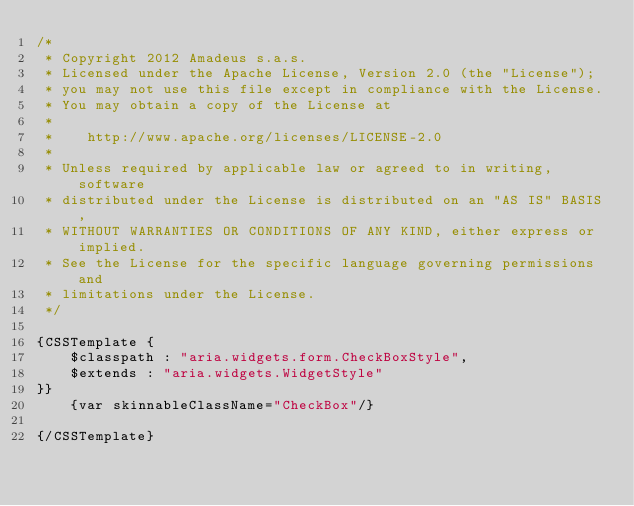Convert code to text. <code><loc_0><loc_0><loc_500><loc_500><_CSS_>/*
 * Copyright 2012 Amadeus s.a.s.
 * Licensed under the Apache License, Version 2.0 (the "License");
 * you may not use this file except in compliance with the License.
 * You may obtain a copy of the License at
 *
 *    http://www.apache.org/licenses/LICENSE-2.0
 *
 * Unless required by applicable law or agreed to in writing, software
 * distributed under the License is distributed on an "AS IS" BASIS,
 * WITHOUT WARRANTIES OR CONDITIONS OF ANY KIND, either express or implied.
 * See the License for the specific language governing permissions and
 * limitations under the License.
 */

{CSSTemplate {
    $classpath : "aria.widgets.form.CheckBoxStyle",
    $extends : "aria.widgets.WidgetStyle"
}}
    {var skinnableClassName="CheckBox"/}
    
{/CSSTemplate}</code> 